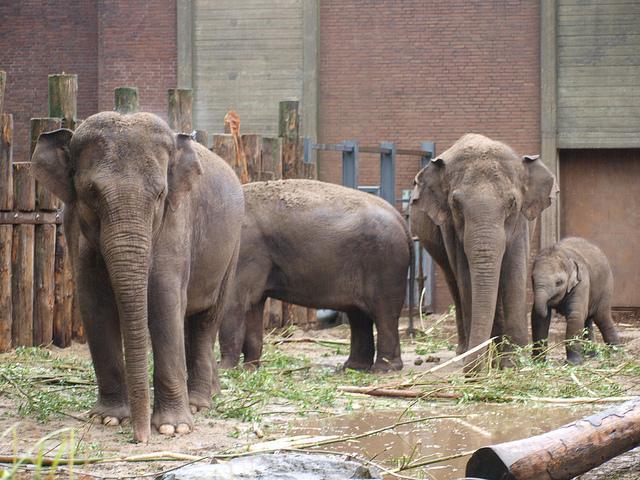How many elephants are there?
Give a very brief answer. 4. How many umbrellas have more than 4 colors?
Give a very brief answer. 0. 